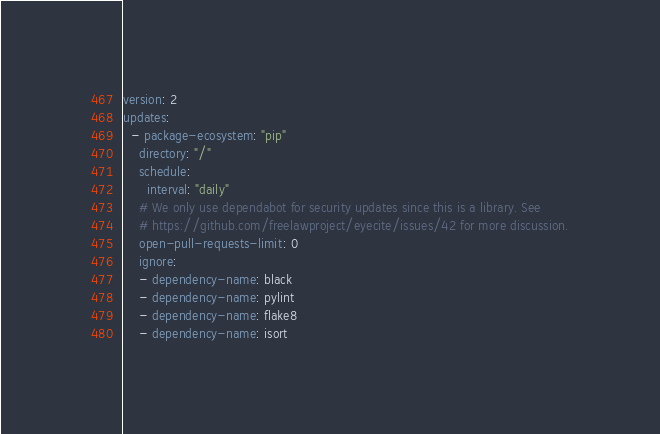Convert code to text. <code><loc_0><loc_0><loc_500><loc_500><_YAML_>version: 2
updates:
  - package-ecosystem: "pip"
    directory: "/"
    schedule:
      interval: "daily"
    # We only use dependabot for security updates since this is a library. See
    # https://github.com/freelawproject/eyecite/issues/42 for more discussion.
    open-pull-requests-limit: 0
    ignore:
    - dependency-name: black
    - dependency-name: pylint
    - dependency-name: flake8
    - dependency-name: isort
</code> 